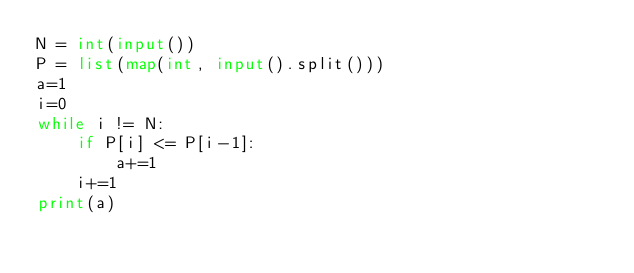<code> <loc_0><loc_0><loc_500><loc_500><_Python_>N = int(input())
P = list(map(int, input().split()))
a=1
i=0
while i != N:
    if P[i] <= P[i-1]:
        a+=1
    i+=1
print(a)
</code> 